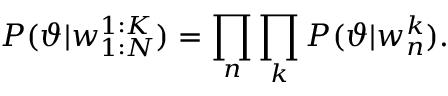Convert formula to latex. <formula><loc_0><loc_0><loc_500><loc_500>P ( \vartheta | w _ { 1 \colon N } ^ { 1 \colon K } ) = \prod _ { n } \prod _ { k } P ( \vartheta | w _ { n } ^ { k } ) .</formula> 